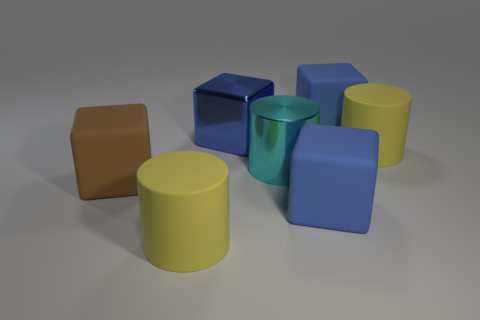There is a large cube that is both behind the big brown object and to the right of the cyan shiny thing; what color is it?
Make the answer very short. Blue. How many objects are big blue rubber objects or yellow matte things in front of the large brown thing?
Your answer should be very brief. 3. What material is the large block in front of the brown thing behind the yellow cylinder in front of the metallic cylinder made of?
Your answer should be very brief. Rubber. Is there any other thing that is the same material as the cyan cylinder?
Keep it short and to the point. Yes. Is the color of the big cylinder behind the big cyan shiny cylinder the same as the big metallic cylinder?
Ensure brevity in your answer.  No. How many blue objects are either matte blocks or large metal spheres?
Your answer should be compact. 2. How many other things are there of the same shape as the cyan metal object?
Your answer should be compact. 2. Are the cyan thing and the big brown block made of the same material?
Your answer should be compact. No. There is a large object that is both right of the cyan metallic object and in front of the cyan metallic cylinder; what is it made of?
Offer a terse response. Rubber. The rubber cylinder that is to the left of the metallic block is what color?
Give a very brief answer. Yellow. 